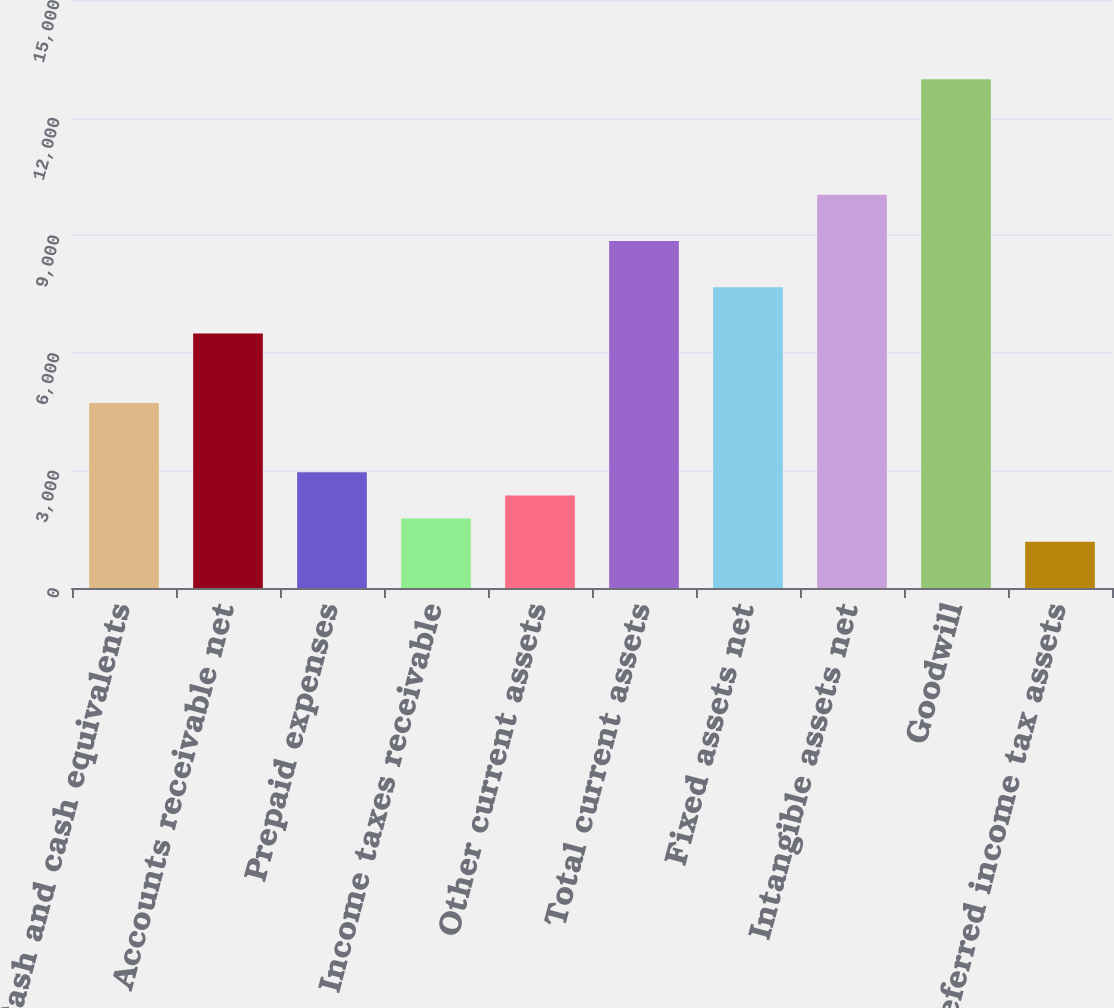Convert chart to OTSL. <chart><loc_0><loc_0><loc_500><loc_500><bar_chart><fcel>Cash and cash equivalents<fcel>Accounts receivable net<fcel>Prepaid expenses<fcel>Income taxes receivable<fcel>Other current assets<fcel>Total current assets<fcel>Fixed assets net<fcel>Intangible assets net<fcel>Goodwill<fcel>Deferred income tax assets<nl><fcel>4720.26<fcel>6490.32<fcel>2950.2<fcel>1770.16<fcel>2360.18<fcel>8850.4<fcel>7670.36<fcel>10030.4<fcel>12980.5<fcel>1180.14<nl></chart> 